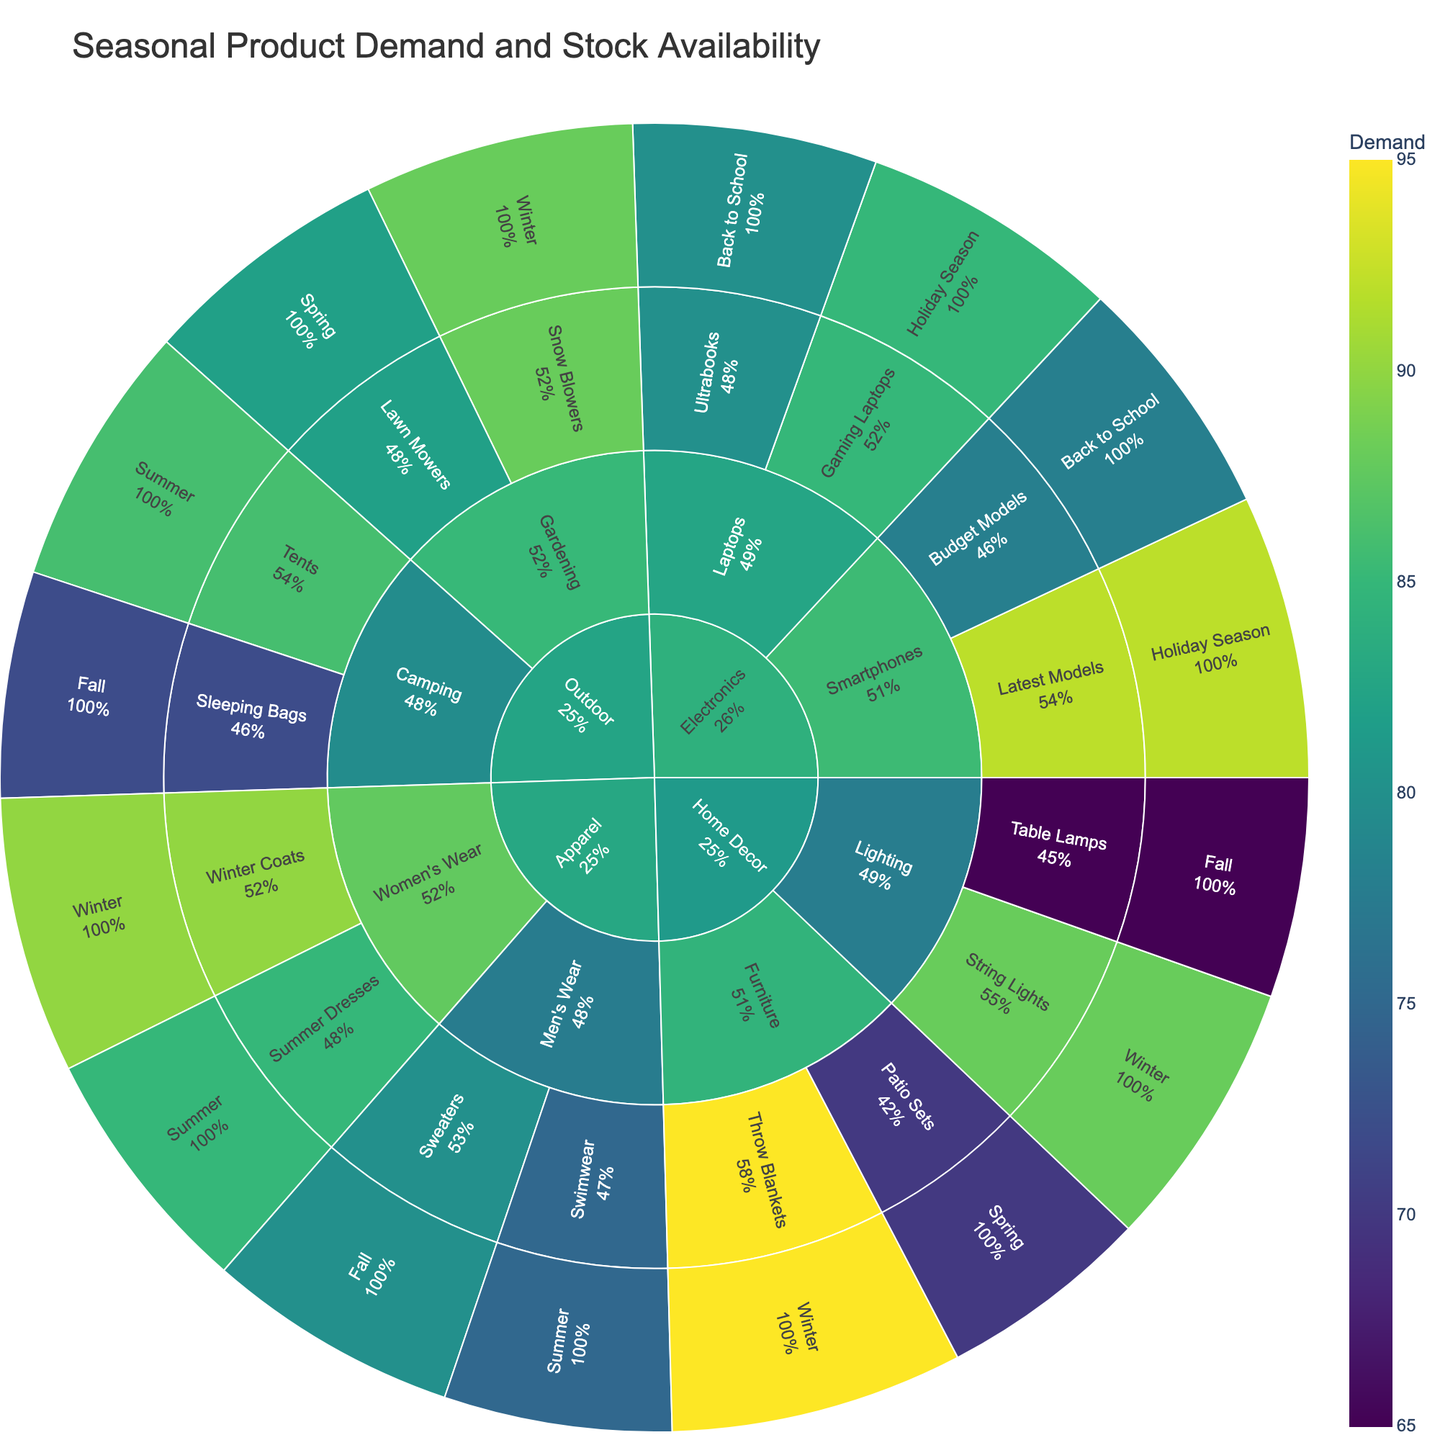How many total departments are represented in the plot? There are four departments represented: Apparel, Home Decor, Electronics, and Outdoor. This can be seen at the root level of the sunburst plot.
Answer: Four Which season shows the highest demand for products overall? To identify the season with the highest demand, look at the outermost segments representing each season and compare their sizes. Summer appears to have significant segments, especially in the Apparel and Outdoor departments.
Answer: Summer Which product has the highest stock availability within the Home Decor department? Focus on the Home Decor department and its segments. The Home Decor department has Furniture and Lighting categories. Throw Blankets within Furniture shows a stock availability of 85, which is higher than others.
Answer: Throw Blankets What is the difference in demand between Winter Coats in Women's Wear and Sweaters in Men's Wear within the Apparel department? Winter Coats have a demand of 90, and Sweaters have a demand of 80. The difference is 90 - 80 = 10.
Answer: 10 Which category within the Outdoor department has the lowest stock availability? Compare the stock availability values within the Gardening and Camping categories in the Outdoor department. Lawn Mowers in Gardening and Tents in Camping have lower stocks, with Lawn Mowers showing 72, which appears to be the lowest.
Answer: Lawn Mowers Is the average stock availability for Electronics products in the Holiday Season greater than that for products in the Back to School season? Calculate the average stock for products in each season. For Holiday Season: (82 + 75)/2 = 78.5, and for Back to School: (73 + 70)/2 = 71.5. Compare the two averages.
Answer: Yes Which department has the most balanced demand and stock availability distribution? The department where the values of demand and stock are closest for most products is taken as the most balanced. In the Electronics department, the demand and stock values are closer compared to other departments.
Answer: Electronics Which product in the Apparel department has the highest percentage of demand relative to its stock availability? Calculate the percentage of demand relative to stock for each product in the Apparel department. For example, Summer Dresses have a demand of 85 and stock of 70, yielding 85/70 = 1.21 or 121%. Winter Coats similarly yields 90/80 = 1.125 or 112.5%. Swimwear yields 75/65 = 1.15 or 115%, and Sweaters yield 80/75 = 1.066 or 106.6%. Therefore, Summer Dresses have the highest percentage.
Answer: Summer Dresses 